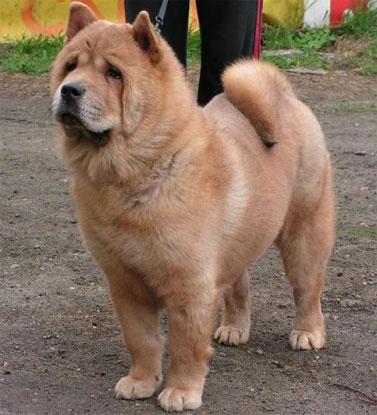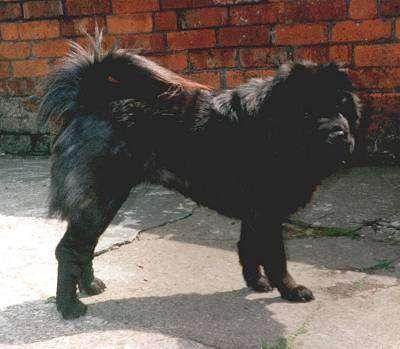The first image is the image on the left, the second image is the image on the right. For the images shown, is this caption "The left and right image contains the same number of dogs one dark brown and the other light brown." true? Answer yes or no. Yes. The first image is the image on the left, the second image is the image on the right. Considering the images on both sides, is "The dog in the image on the right is lying down." valid? Answer yes or no. No. 